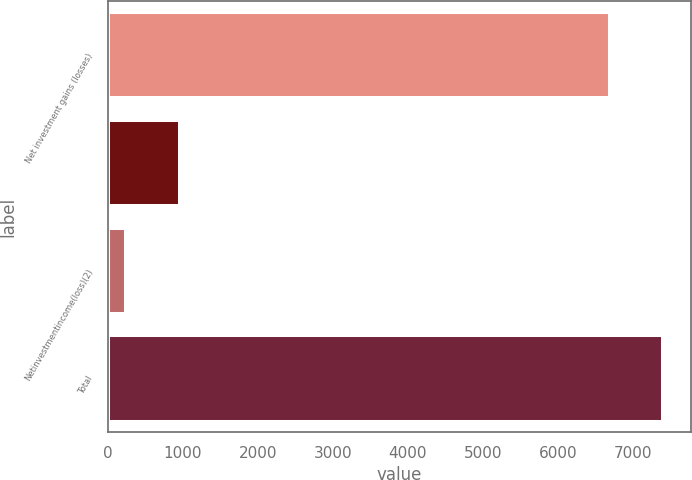<chart> <loc_0><loc_0><loc_500><loc_500><bar_chart><fcel>Net investment gains (losses)<fcel>Unnamed: 1<fcel>Netinvestmentincome(loss)(2)<fcel>Total<nl><fcel>6688<fcel>956.5<fcel>240<fcel>7405<nl></chart> 